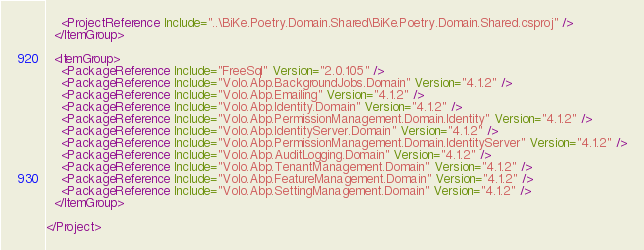<code> <loc_0><loc_0><loc_500><loc_500><_XML_>    <ProjectReference Include="..\BiKe.Poetry.Domain.Shared\BiKe.Poetry.Domain.Shared.csproj" />
  </ItemGroup>

  <ItemGroup>
    <PackageReference Include="FreeSql" Version="2.0.105" />
    <PackageReference Include="Volo.Abp.BackgroundJobs.Domain" Version="4.1.2" />
    <PackageReference Include="Volo.Abp.Emailing" Version="4.1.2" />
    <PackageReference Include="Volo.Abp.Identity.Domain" Version="4.1.2" />
    <PackageReference Include="Volo.Abp.PermissionManagement.Domain.Identity" Version="4.1.2" />
    <PackageReference Include="Volo.Abp.IdentityServer.Domain" Version="4.1.2" />
    <PackageReference Include="Volo.Abp.PermissionManagement.Domain.IdentityServer" Version="4.1.2" />
    <PackageReference Include="Volo.Abp.AuditLogging.Domain" Version="4.1.2" />
    <PackageReference Include="Volo.Abp.TenantManagement.Domain" Version="4.1.2" />
    <PackageReference Include="Volo.Abp.FeatureManagement.Domain" Version="4.1.2" />
    <PackageReference Include="Volo.Abp.SettingManagement.Domain" Version="4.1.2" />
  </ItemGroup>

</Project>
</code> 